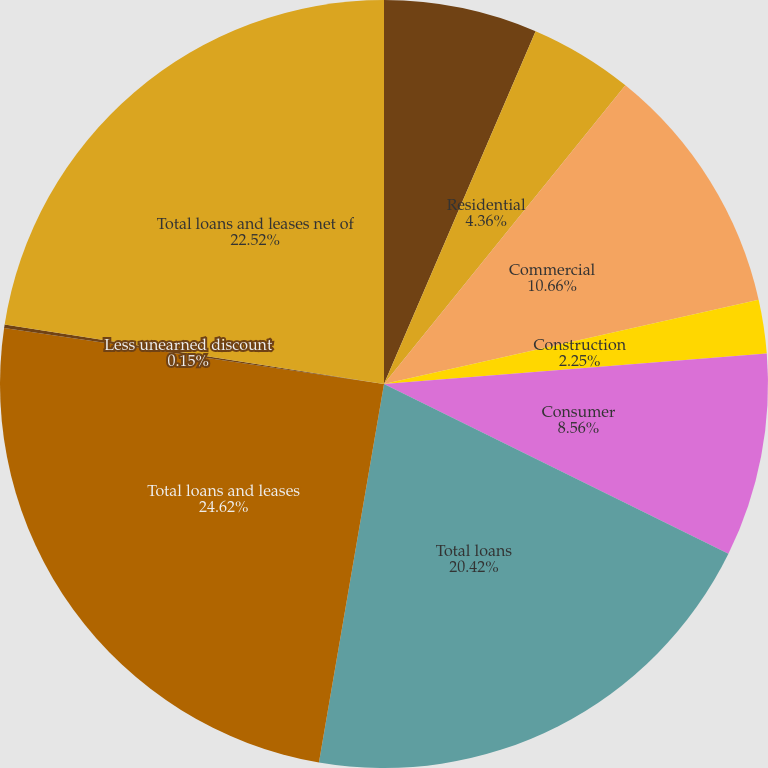<chart> <loc_0><loc_0><loc_500><loc_500><pie_chart><fcel>Commercial financial etc<fcel>Residential<fcel>Commercial<fcel>Construction<fcel>Consumer<fcel>Total loans<fcel>Total loans and leases<fcel>Less unearned discount<fcel>Total loans and leases net of<nl><fcel>6.46%<fcel>4.36%<fcel>10.66%<fcel>2.25%<fcel>8.56%<fcel>20.42%<fcel>24.62%<fcel>0.15%<fcel>22.52%<nl></chart> 